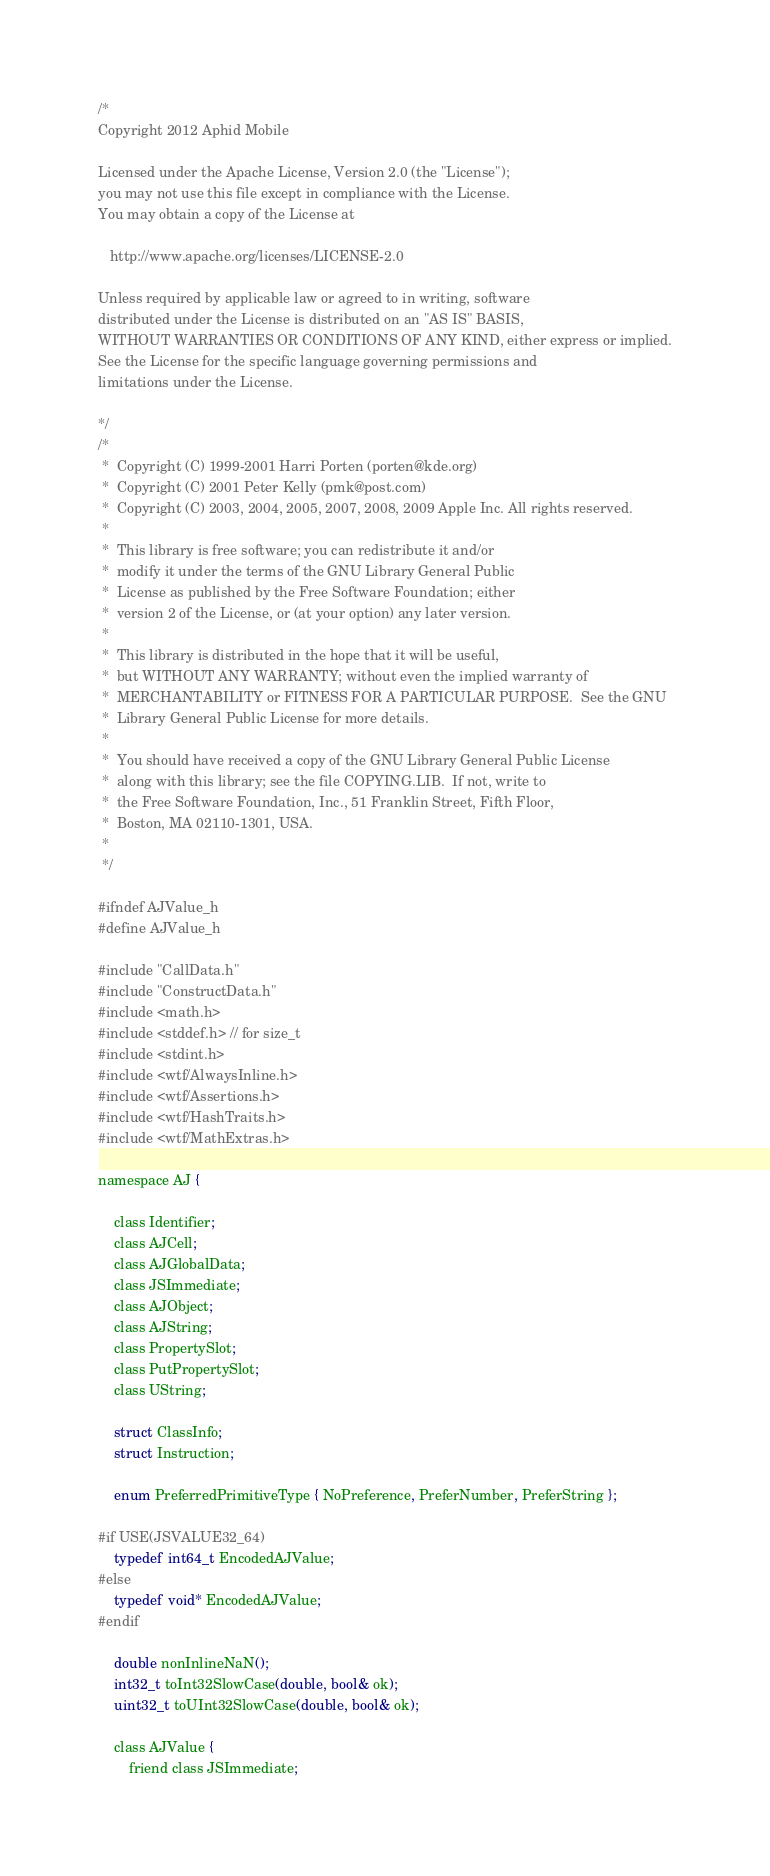Convert code to text. <code><loc_0><loc_0><loc_500><loc_500><_C_>
/*
Copyright 2012 Aphid Mobile

Licensed under the Apache License, Version 2.0 (the "License");
you may not use this file except in compliance with the License.
You may obtain a copy of the License at
 
   http://www.apache.org/licenses/LICENSE-2.0

Unless required by applicable law or agreed to in writing, software
distributed under the License is distributed on an "AS IS" BASIS,
WITHOUT WARRANTIES OR CONDITIONS OF ANY KIND, either express or implied.
See the License for the specific language governing permissions and
limitations under the License.

*/
/*
 *  Copyright (C) 1999-2001 Harri Porten (porten@kde.org)
 *  Copyright (C) 2001 Peter Kelly (pmk@post.com)
 *  Copyright (C) 2003, 2004, 2005, 2007, 2008, 2009 Apple Inc. All rights reserved.
 *
 *  This library is free software; you can redistribute it and/or
 *  modify it under the terms of the GNU Library General Public
 *  License as published by the Free Software Foundation; either
 *  version 2 of the License, or (at your option) any later version.
 *
 *  This library is distributed in the hope that it will be useful,
 *  but WITHOUT ANY WARRANTY; without even the implied warranty of
 *  MERCHANTABILITY or FITNESS FOR A PARTICULAR PURPOSE.  See the GNU
 *  Library General Public License for more details.
 *
 *  You should have received a copy of the GNU Library General Public License
 *  along with this library; see the file COPYING.LIB.  If not, write to
 *  the Free Software Foundation, Inc., 51 Franklin Street, Fifth Floor,
 *  Boston, MA 02110-1301, USA.
 *
 */

#ifndef AJValue_h
#define AJValue_h

#include "CallData.h"
#include "ConstructData.h"
#include <math.h>
#include <stddef.h> // for size_t
#include <stdint.h>
#include <wtf/AlwaysInline.h>
#include <wtf/Assertions.h>
#include <wtf/HashTraits.h>
#include <wtf/MathExtras.h>

namespace AJ {

    class Identifier;
    class AJCell;
    class AJGlobalData;
    class JSImmediate;
    class AJObject;
    class AJString;
    class PropertySlot;
    class PutPropertySlot;
    class UString;

    struct ClassInfo;
    struct Instruction;

    enum PreferredPrimitiveType { NoPreference, PreferNumber, PreferString };

#if USE(JSVALUE32_64)
    typedef int64_t EncodedAJValue;
#else
    typedef void* EncodedAJValue;
#endif

    double nonInlineNaN();
    int32_t toInt32SlowCase(double, bool& ok);
    uint32_t toUInt32SlowCase(double, bool& ok);

    class AJValue {
        friend class JSImmediate;</code> 